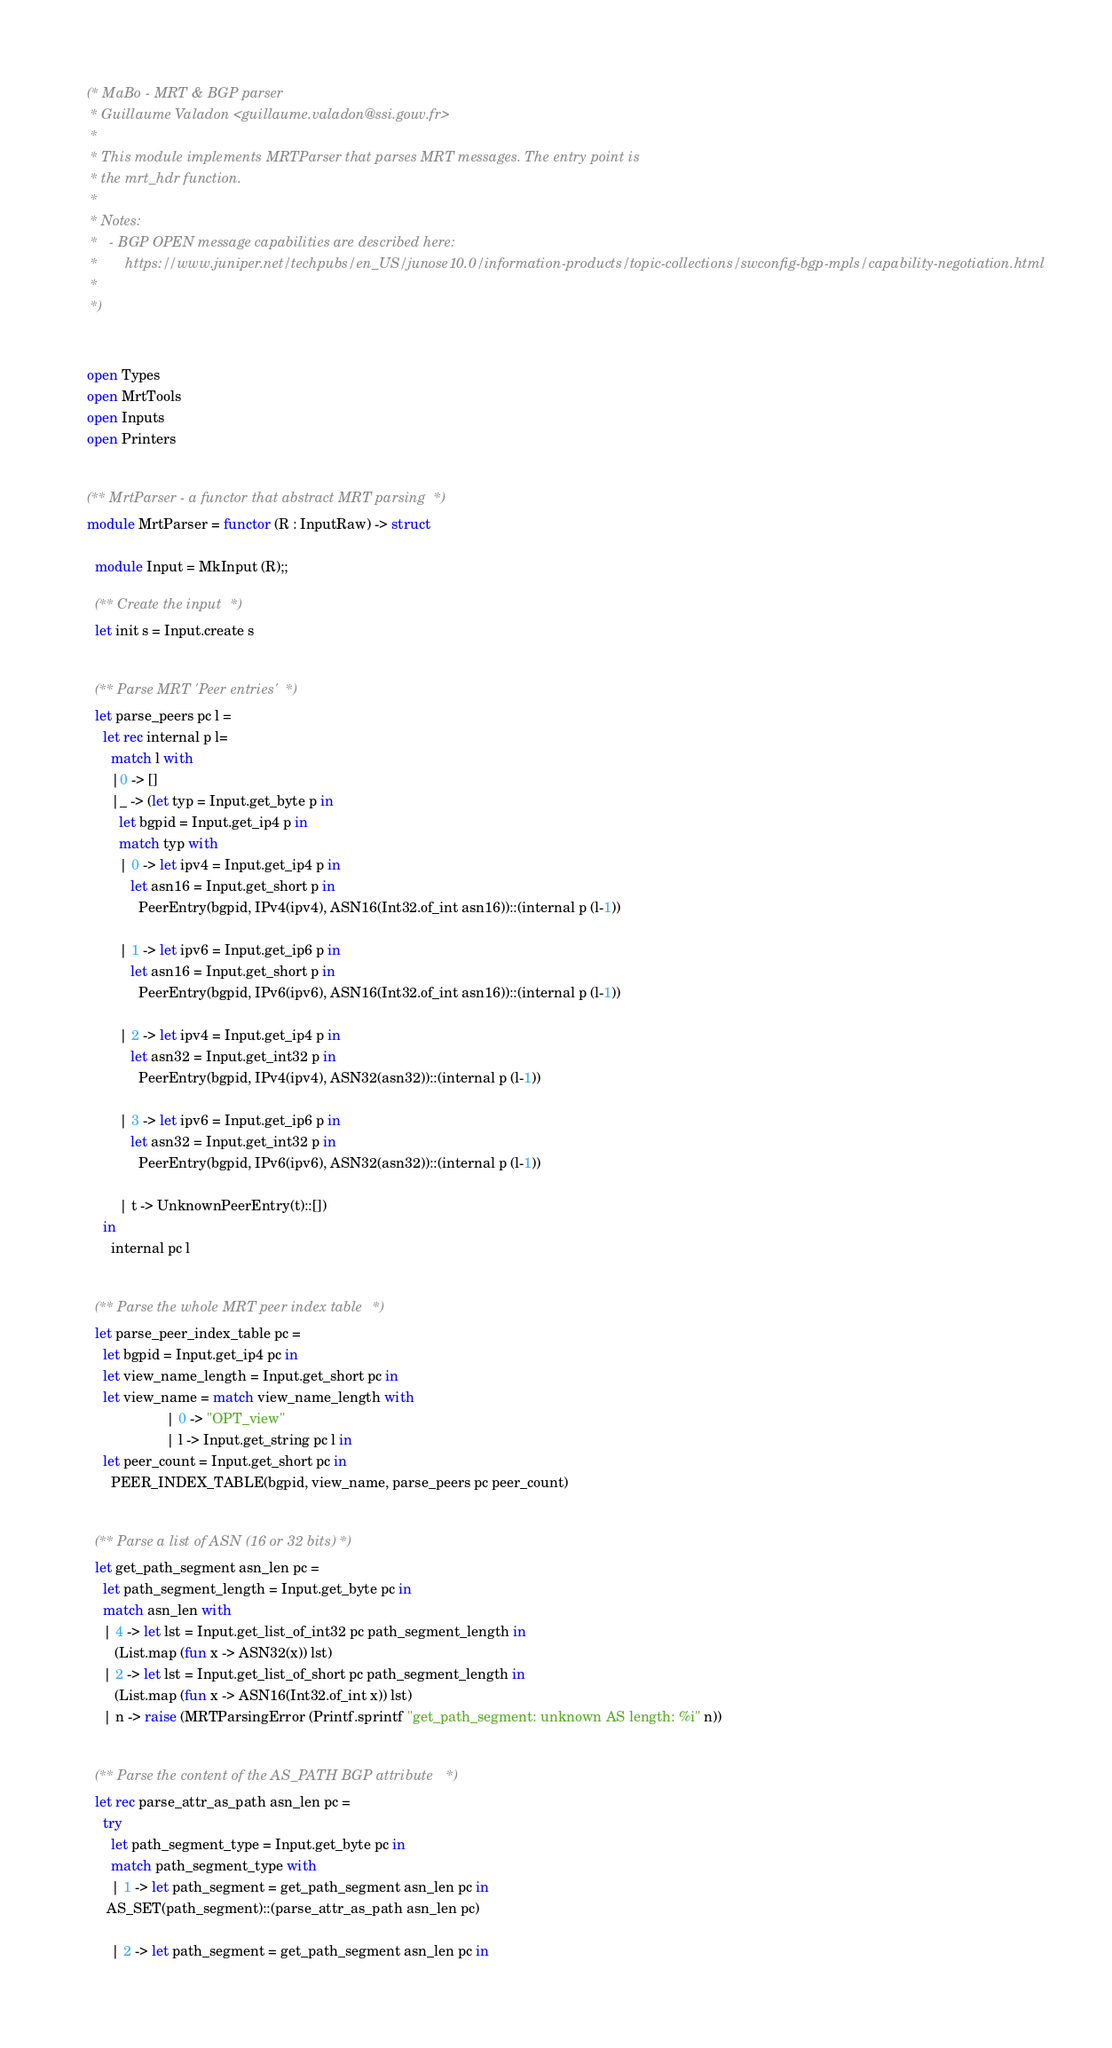<code> <loc_0><loc_0><loc_500><loc_500><_OCaml_>(* MaBo - MRT & BGP parser
 * Guillaume Valadon <guillaume.valadon@ssi.gouv.fr>
 *
 * This module implements MRTParser that parses MRT messages. The entry point is
 * the mrt_hdr function.
 *
 * Notes:
 *   - BGP OPEN message capabilities are described here:
 *       https://www.juniper.net/techpubs/en_US/junose10.0/information-products/topic-collections/swconfig-bgp-mpls/capability-negotiation.html
 *
 *)


open Types
open MrtTools
open Inputs
open Printers


(** MrtParser - a functor that abstract MRT parsing *)
module MrtParser = functor (R : InputRaw) -> struct

  module Input = MkInput (R);;

  (** Create the input *)
  let init s = Input.create s

  
  (** Parse MRT 'Peer entries' *)
  let parse_peers pc l =
    let rec internal p l= 
      match l with
      |0 -> []
      |_ -> (let typ = Input.get_byte p in
	    let bgpid = Input.get_ip4 p in
	    match typ with
	    | 0 -> let ipv4 = Input.get_ip4 p in
		   let asn16 = Input.get_short p in
		     PeerEntry(bgpid, IPv4(ipv4), ASN16(Int32.of_int asn16))::(internal p (l-1))

	    | 1 -> let ipv6 = Input.get_ip6 p in
		   let asn16 = Input.get_short p in
		     PeerEntry(bgpid, IPv6(ipv6), ASN16(Int32.of_int asn16))::(internal p (l-1))

	    | 2 -> let ipv4 = Input.get_ip4 p in
		   let asn32 = Input.get_int32 p in
		     PeerEntry(bgpid, IPv4(ipv4), ASN32(asn32))::(internal p (l-1))

	    | 3 -> let ipv6 = Input.get_ip6 p in
		   let asn32 = Input.get_int32 p in
		     PeerEntry(bgpid, IPv6(ipv6), ASN32(asn32))::(internal p (l-1))

	    | t -> UnknownPeerEntry(t)::[])
    in
      internal pc l


  (** Parse the whole MRT peer index table *)
  let parse_peer_index_table pc =
    let bgpid = Input.get_ip4 pc in
    let view_name_length = Input.get_short pc in
    let view_name = match view_name_length with
                    | 0 -> "OPT_view"
                    | l -> Input.get_string pc l in
    let peer_count = Input.get_short pc in
      PEER_INDEX_TABLE(bgpid, view_name, parse_peers pc peer_count)


  (** Parse a list of ASN (16 or 32 bits) *)
  let get_path_segment asn_len pc =
    let path_segment_length = Input.get_byte pc in
    match asn_len with
    | 4 -> let lst = Input.get_list_of_int32 pc path_segment_length in
	   (List.map (fun x -> ASN32(x)) lst)
    | 2 -> let lst = Input.get_list_of_short pc path_segment_length in
	   (List.map (fun x -> ASN16(Int32.of_int x)) lst)
    | n -> raise (MRTParsingError (Printf.sprintf "get_path_segment: unknown AS length: %i" n))


  (** Parse the content of the AS_PATH BGP attribute *)
  let rec parse_attr_as_path asn_len pc =
    try
      let path_segment_type = Input.get_byte pc in
      match path_segment_type with
      | 1 -> let path_segment = get_path_segment asn_len pc in
	 AS_SET(path_segment)::(parse_attr_as_path asn_len pc)

      | 2 -> let path_segment = get_path_segment asn_len pc in</code> 